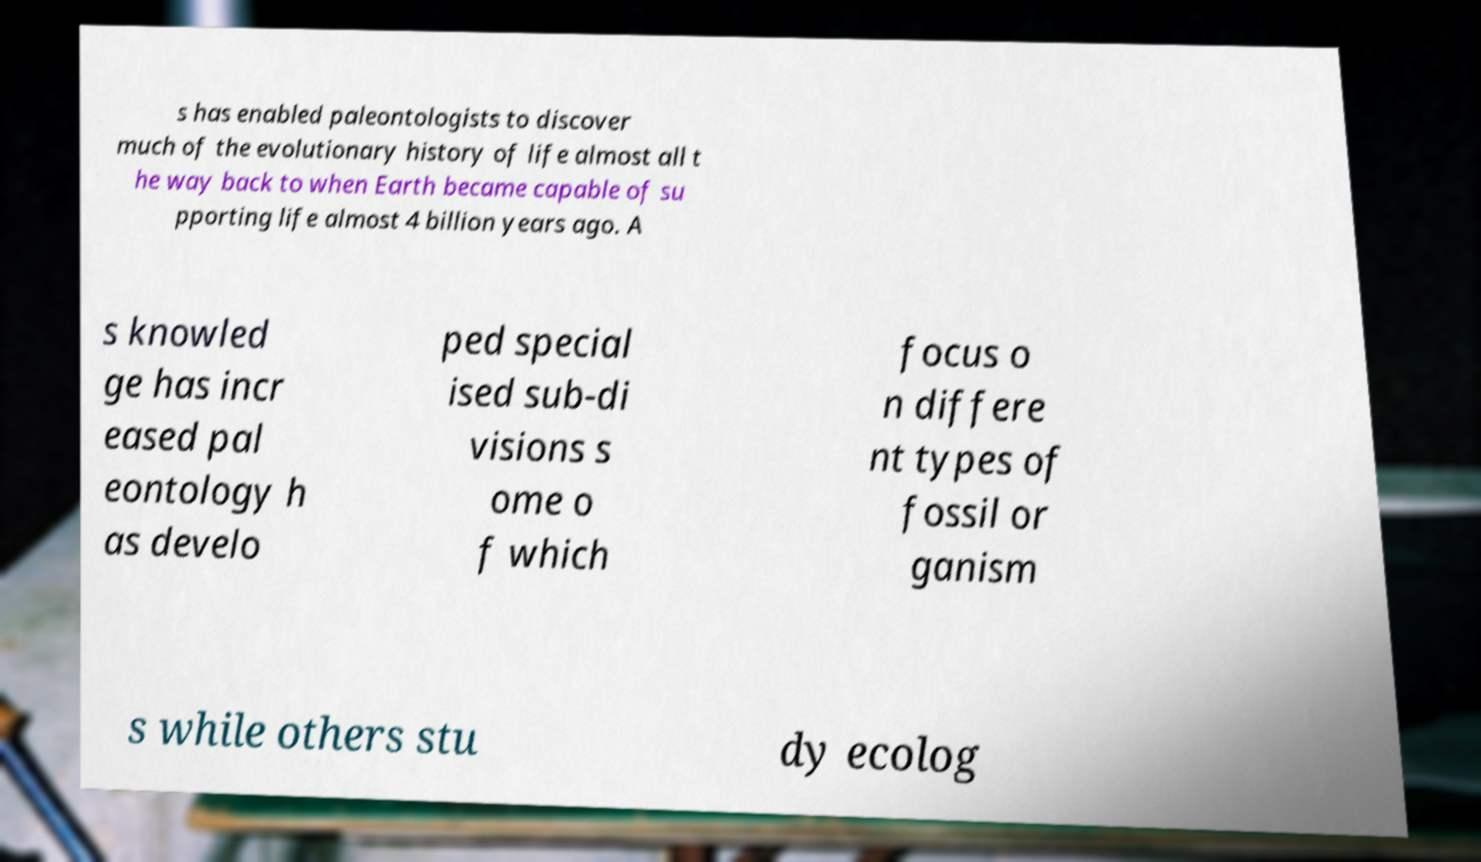There's text embedded in this image that I need extracted. Can you transcribe it verbatim? s has enabled paleontologists to discover much of the evolutionary history of life almost all t he way back to when Earth became capable of su pporting life almost 4 billion years ago. A s knowled ge has incr eased pal eontology h as develo ped special ised sub-di visions s ome o f which focus o n differe nt types of fossil or ganism s while others stu dy ecolog 